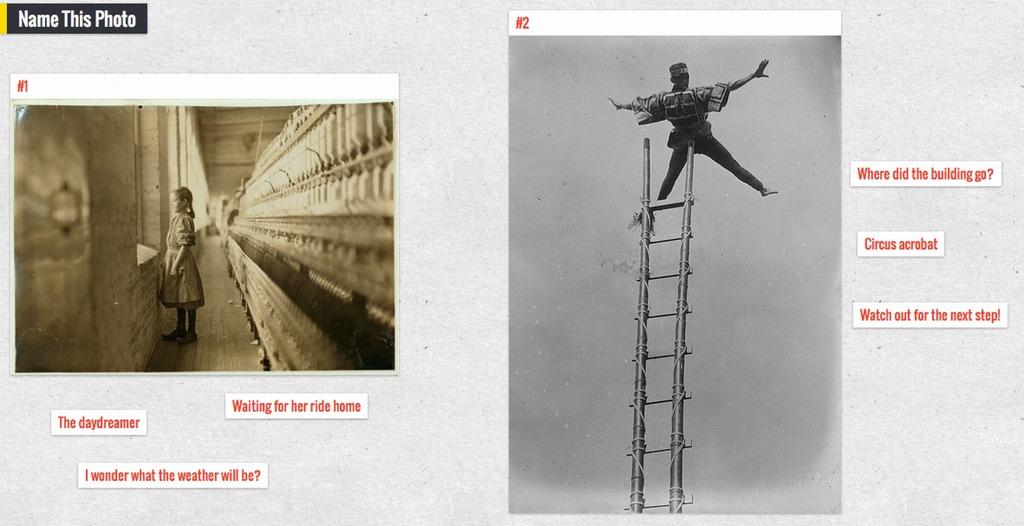What is the daydreamer thinking?
Keep it short and to the point. I wonder what the weather will be?. What are you supposed to do to the photo according to the top left?
Offer a terse response. Name this photo. 